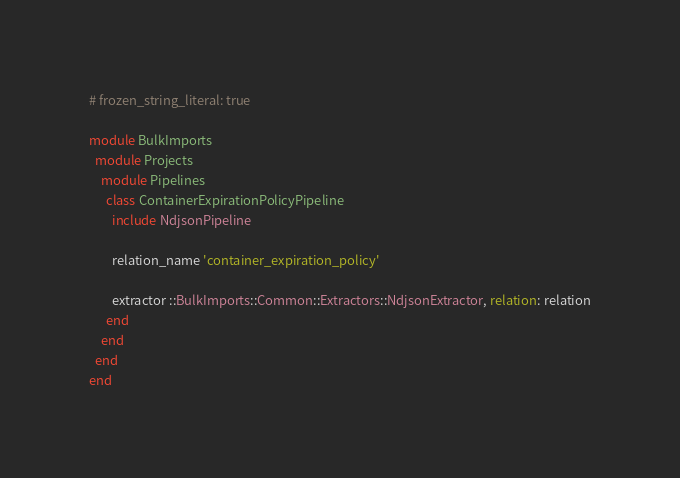<code> <loc_0><loc_0><loc_500><loc_500><_Ruby_># frozen_string_literal: true

module BulkImports
  module Projects
    module Pipelines
      class ContainerExpirationPolicyPipeline
        include NdjsonPipeline

        relation_name 'container_expiration_policy'

        extractor ::BulkImports::Common::Extractors::NdjsonExtractor, relation: relation
      end
    end
  end
end
</code> 